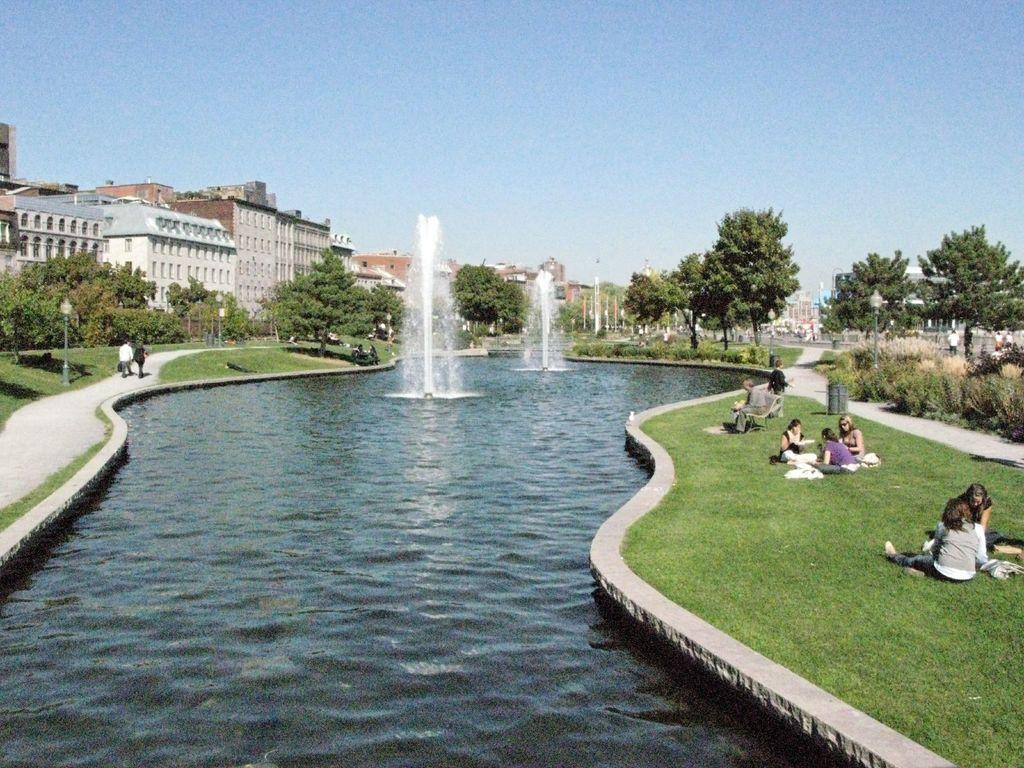In one or two sentences, can you explain what this image depicts? In this picture we can see small water pond with two fountain. On the right side we can see group of girls sitting in the garden. On the left side we can see some buildings and walking area. 